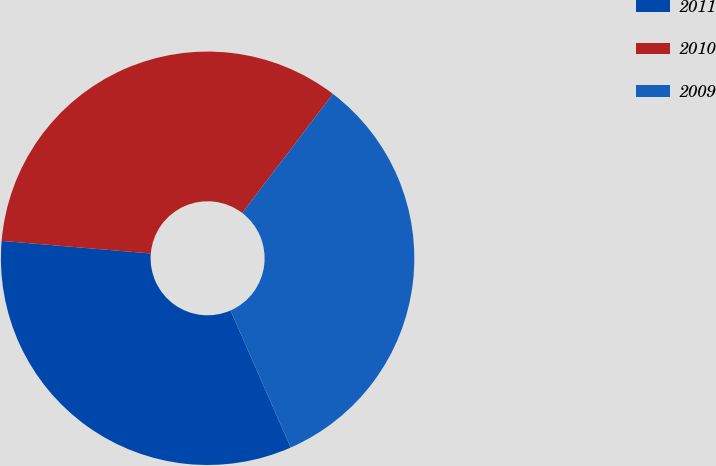Convert chart. <chart><loc_0><loc_0><loc_500><loc_500><pie_chart><fcel>2011<fcel>2010<fcel>2009<nl><fcel>32.93%<fcel>34.03%<fcel>33.04%<nl></chart> 